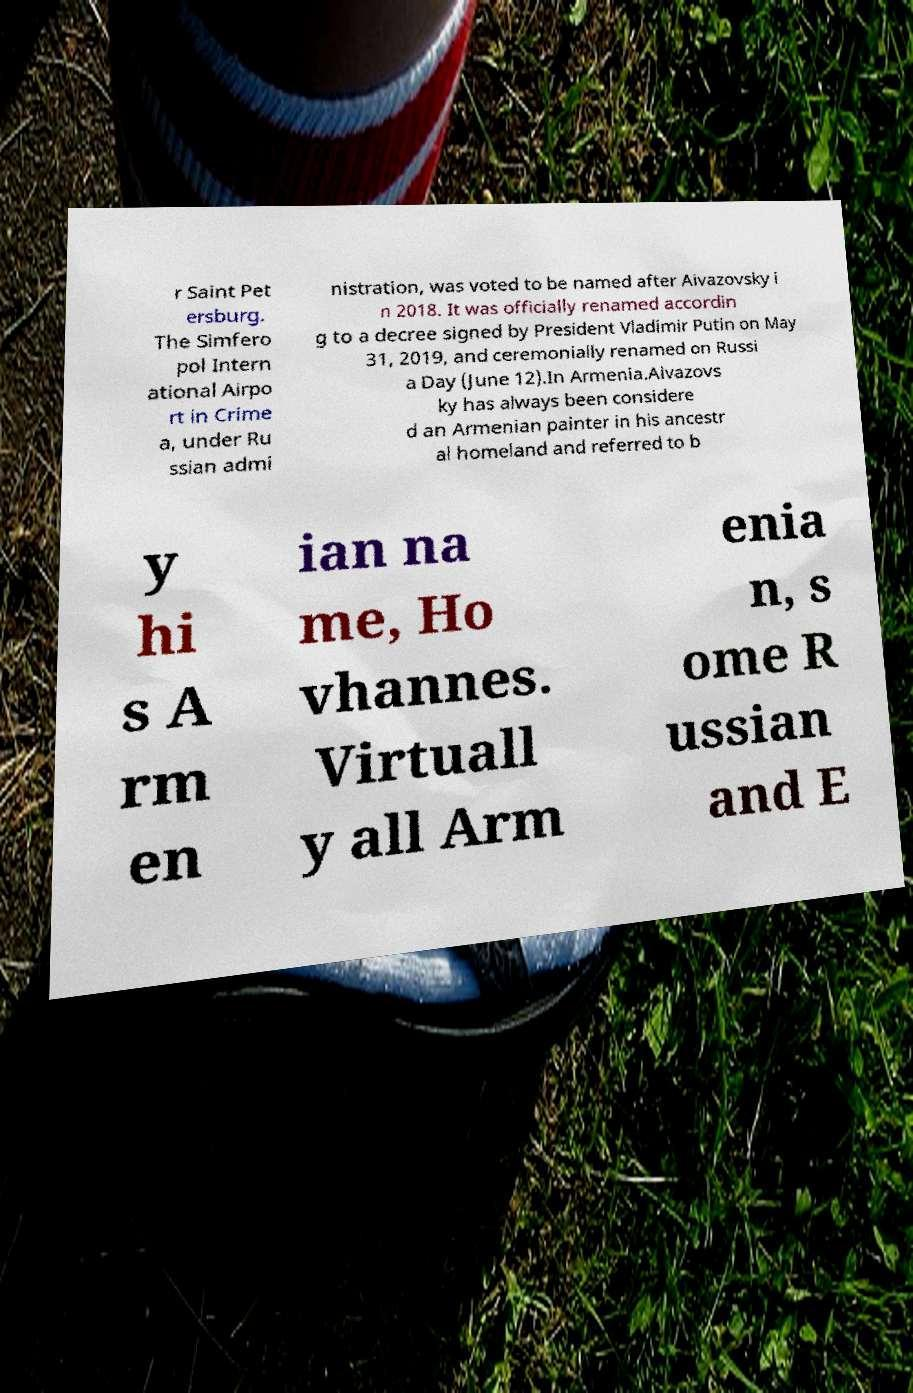Could you extract and type out the text from this image? r Saint Pet ersburg. The Simfero pol Intern ational Airpo rt in Crime a, under Ru ssian admi nistration, was voted to be named after Aivazovsky i n 2018. It was officially renamed accordin g to a decree signed by President Vladimir Putin on May 31, 2019, and ceremonially renamed on Russi a Day (June 12).In Armenia.Aivazovs ky has always been considere d an Armenian painter in his ancestr al homeland and referred to b y hi s A rm en ian na me, Ho vhannes. Virtuall y all Arm enia n, s ome R ussian and E 